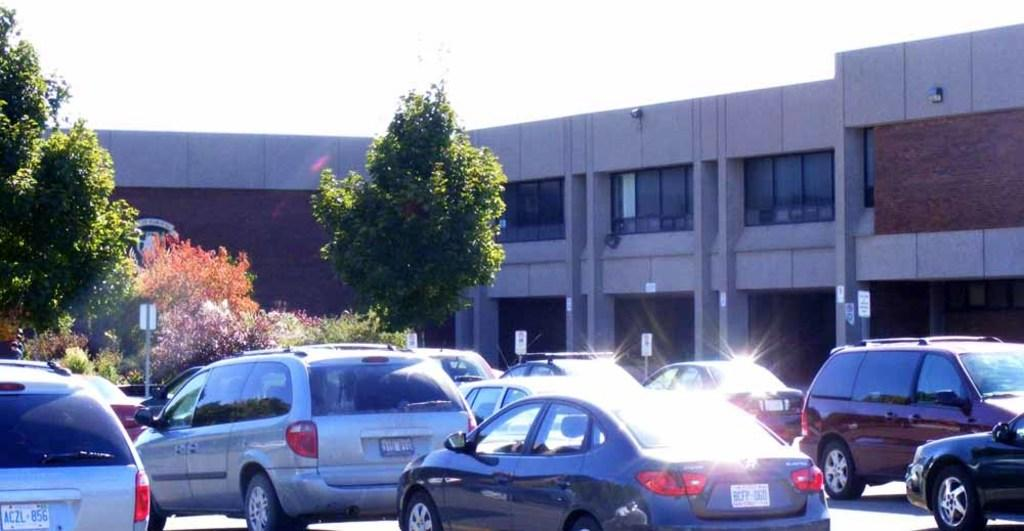What is happening on the road in the image? There are cars moving on the road. What can be seen on the left side of the road? There are trees on the left side of the road. What is located on the right side of the road? There is a building on the right side of the road. What is the weight of the police officer standing near the building? There is no police officer present in the image, so it is not possible to determine their weight. 